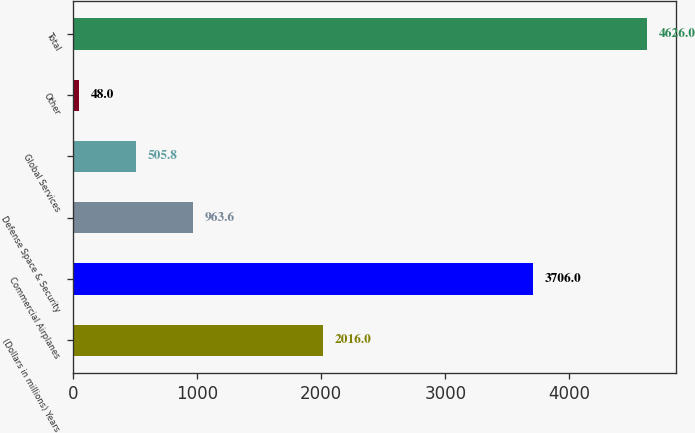Convert chart. <chart><loc_0><loc_0><loc_500><loc_500><bar_chart><fcel>(Dollars in millions) Years<fcel>Commercial Airplanes<fcel>Defense Space & Security<fcel>Global Services<fcel>Other<fcel>Total<nl><fcel>2016<fcel>3706<fcel>963.6<fcel>505.8<fcel>48<fcel>4626<nl></chart> 